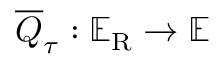Convert formula to latex. <formula><loc_0><loc_0><loc_500><loc_500>\overline { { \ u { Q } } } _ { \ u { \tau } } \colon \mathbb { E } _ { R } \rightarrow \mathbb { E }</formula> 